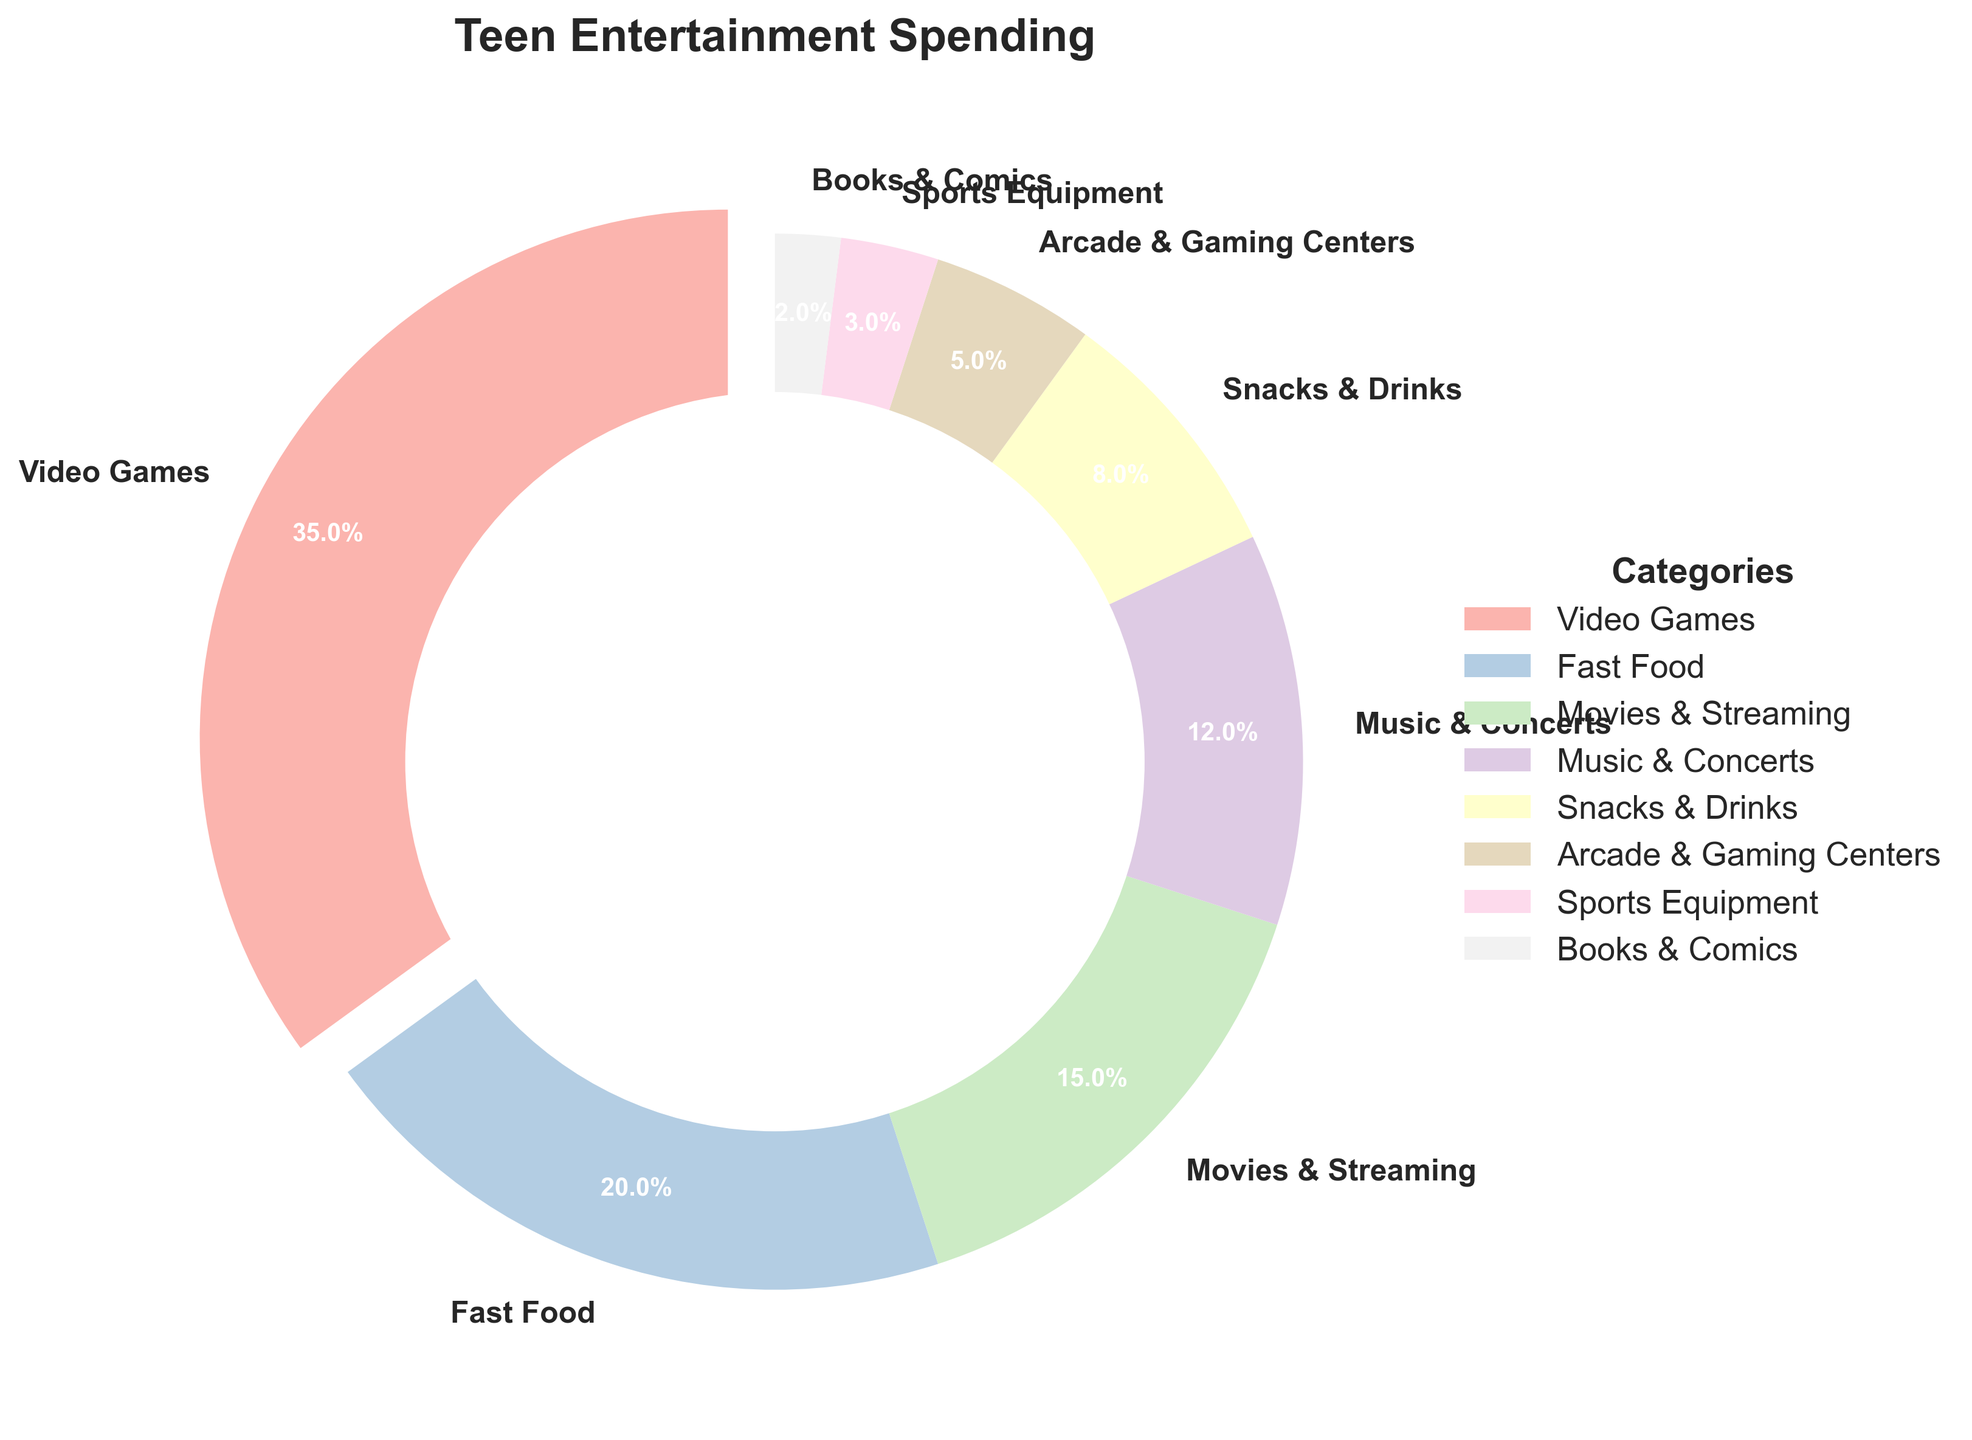What's the largest spending category for teenagers? The largest section of the pie chart is the one with the biggest slice and the label "Video Games" with 35%.
Answer: Video Games How much more do teenagers spend on Video Games compared to Movies & Streaming? According to the chart, Video Games account for 35% and Movies & Streaming 15%. The difference is 35% - 15% = 20%.
Answer: 20% Which category has the smallest spending percentage? The smallest slice on the chart is labeled "Books & Comics" with 2%.
Answer: Books & Comics What are the combined spending percentages for Music & Concerts and Snacks & Drinks? The pie chart shows Music & Concerts at 12% and Snacks & Drinks at 8%. Adding them together gives 12% + 8% = 20%.
Answer: 20% Is the proportion of spending on Fast Food greater than, less than, or equal to that on Movies & Streaming? Fast Food is 20%, and Movies & Streaming is 15% according to the pie chart. Therefore, Fast Food is greater.
Answer: Greater than What's the total spending percentage for categories that individually have less than 10% of spending? Categories with less than 10% are Snacks & Drinks (8%), Arcade & Gaming Centers (5%), Sports Equipment (3%), and Books & Comics (2%). Sum is 8% + 5% + 3% + 2% = 18%.
Answer: 18% What color represents the Video Games category in the pie chart? Assuming a pastel color palette was used, Video Games should be noticeably different from the others since it is the largest slice with an exploded section.
Answer: Pastel color (varying by specific color scheme) Which two categories come immediately after Video Games in terms of spending percentage? After Video Games at 35%, the next largest slices are labeled Fast Food at 20% and Movies & Streaming at 15%.
Answer: Fast Food and Movies & Streaming How much less do teenagers spend on Arcade & Gaming Centers compared to Fast Food? The chart indicates Arcade & Gaming Centers at 5% and Fast Food at 20%. The difference is 20% - 5% = 15%.
Answer: 15% What percentage of spending is allotted to categories related to food (Fast Food, Snacks & Drinks)? The food-related categories are Fast Food (20%) and Snacks & Drinks (8%). Summing these gives 20% + 8% = 28%.
Answer: 28% 